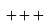Convert formula to latex. <formula><loc_0><loc_0><loc_500><loc_500>+ + +</formula> 